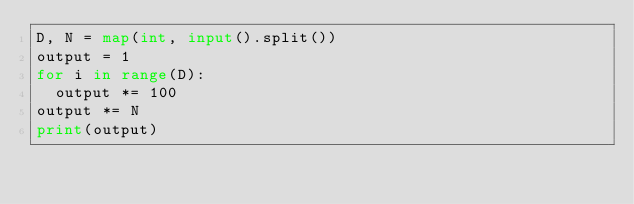<code> <loc_0><loc_0><loc_500><loc_500><_Python_>D, N = map(int, input().split())
output = 1
for i in range(D):
	output *= 100
output *= N
print(output)
</code> 